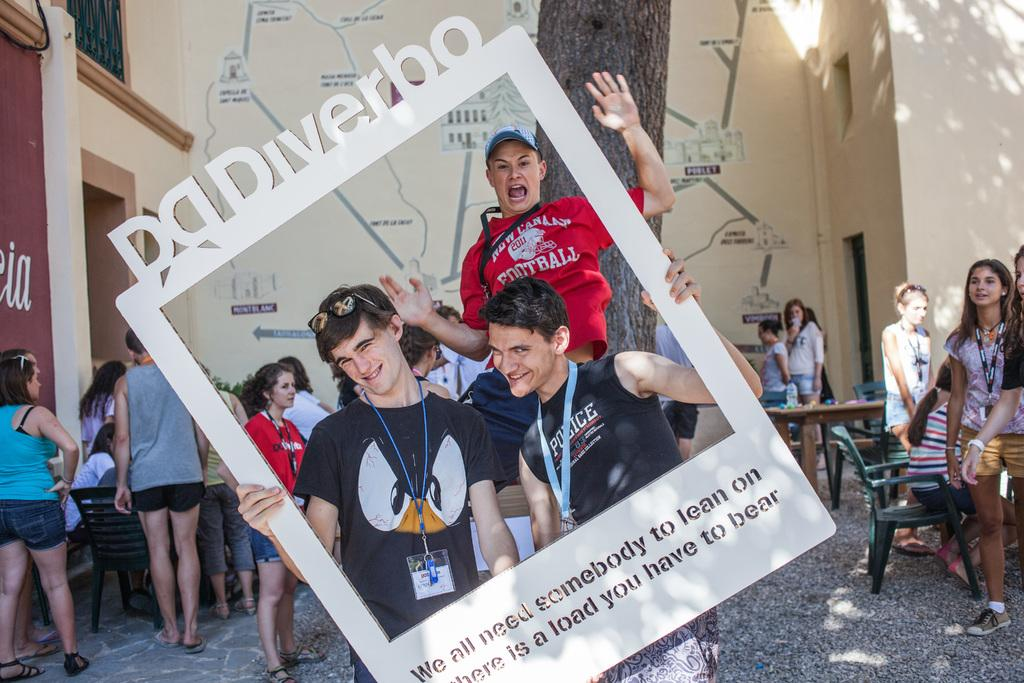How many people are in the image? There are people in the image, but the exact number is not specified. What are two people doing in the image? Two people are holding a white frame in the image. What type of furniture can be seen in the image? Chairs and tables are present in the image. What natural elements can be seen in the image? Trees are visible in the image. What type of structure is in the image? There is a building in the image. What color is the wall in the image? The wall in the image is cream-colored. What is the tendency of the calendar in the image? There is no calendar present in the image, so it is not possible to determine its tendency. 